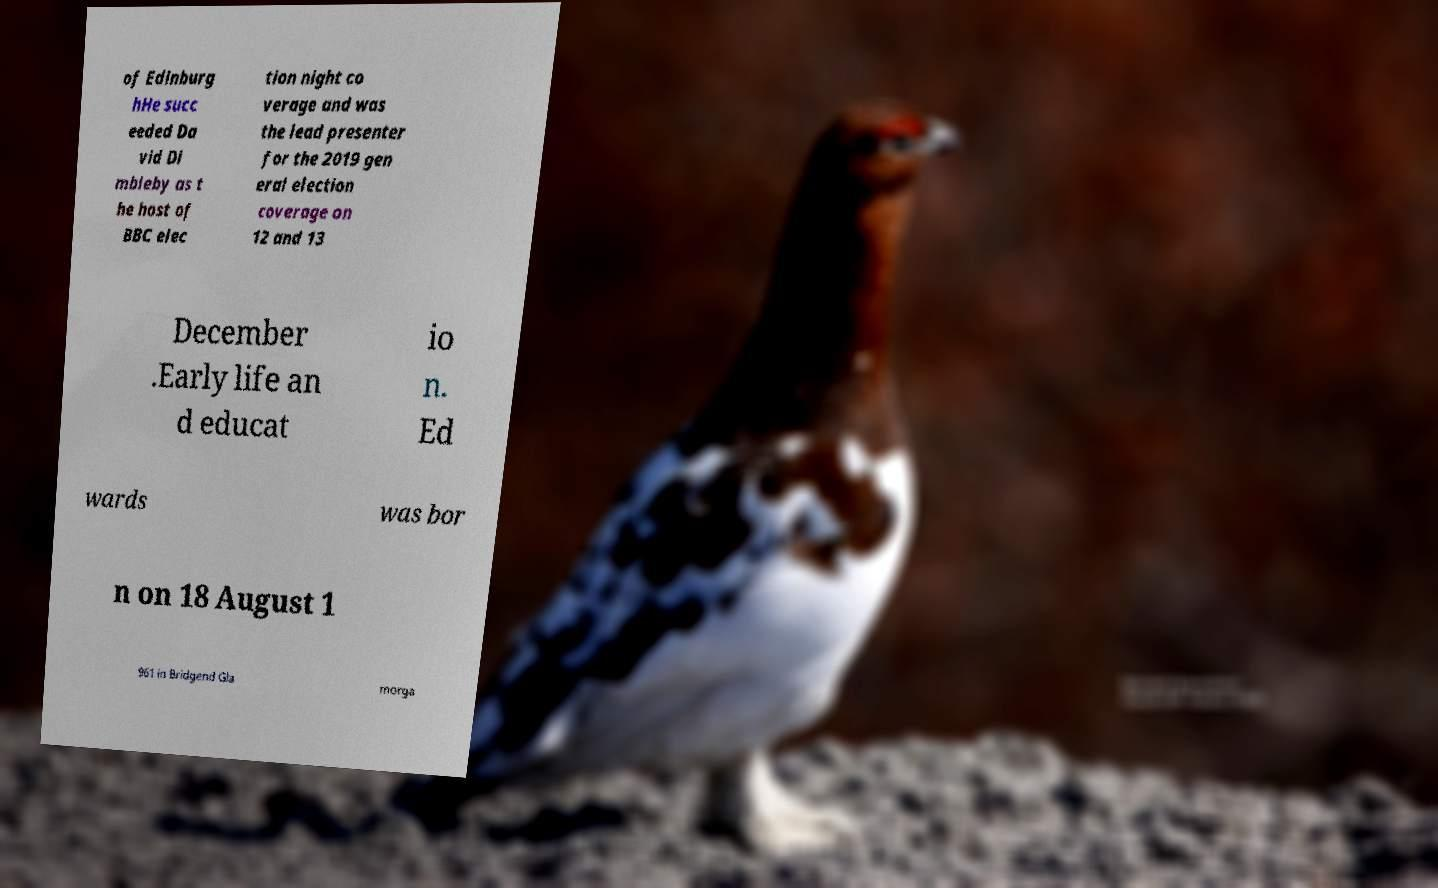For documentation purposes, I need the text within this image transcribed. Could you provide that? of Edinburg hHe succ eeded Da vid Di mbleby as t he host of BBC elec tion night co verage and was the lead presenter for the 2019 gen eral election coverage on 12 and 13 December .Early life an d educat io n. Ed wards was bor n on 18 August 1 961 in Bridgend Gla morga 